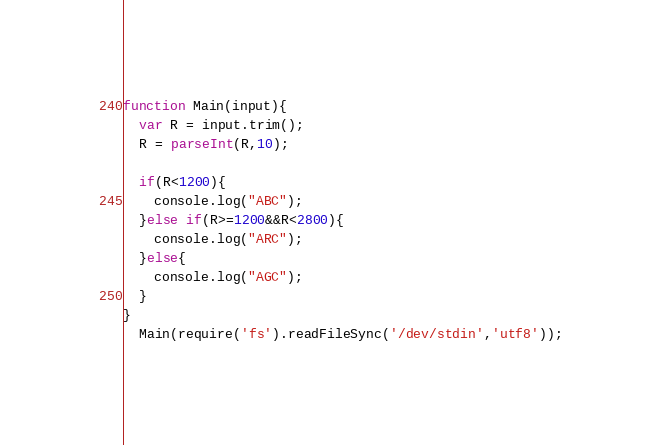Convert code to text. <code><loc_0><loc_0><loc_500><loc_500><_JavaScript_>function Main(input){
  var R = input.trim();
  R = parseInt(R,10);

  if(R<1200){
    console.log("ABC");
  }else if(R>=1200&&R<2800){
    console.log("ARC");
  }else{
    console.log("AGC");
  }
}
  Main(require('fs').readFileSync('/dev/stdin','utf8'));

</code> 